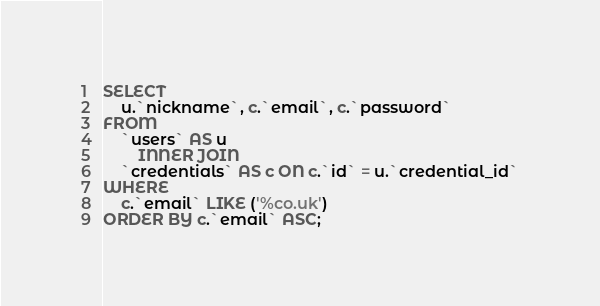Convert code to text. <code><loc_0><loc_0><loc_500><loc_500><_SQL_>SELECT 
    u.`nickname`, c.`email`, c.`password`
FROM
    `users` AS u
        INNER JOIN
    `credentials` AS c ON c.`id` = u.`credential_id`
WHERE
    c.`email` LIKE ('%co.uk')
ORDER BY c.`email` ASC;</code> 